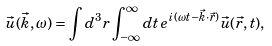<formula> <loc_0><loc_0><loc_500><loc_500>\vec { u } ( \vec { k } , \omega ) = \int d ^ { 3 } r \int _ { - \infty } ^ { \infty } d t \, e ^ { i ( \omega t - \vec { k } \cdot \vec { r } ) } \vec { u } ( \vec { r } , t ) ,</formula> 